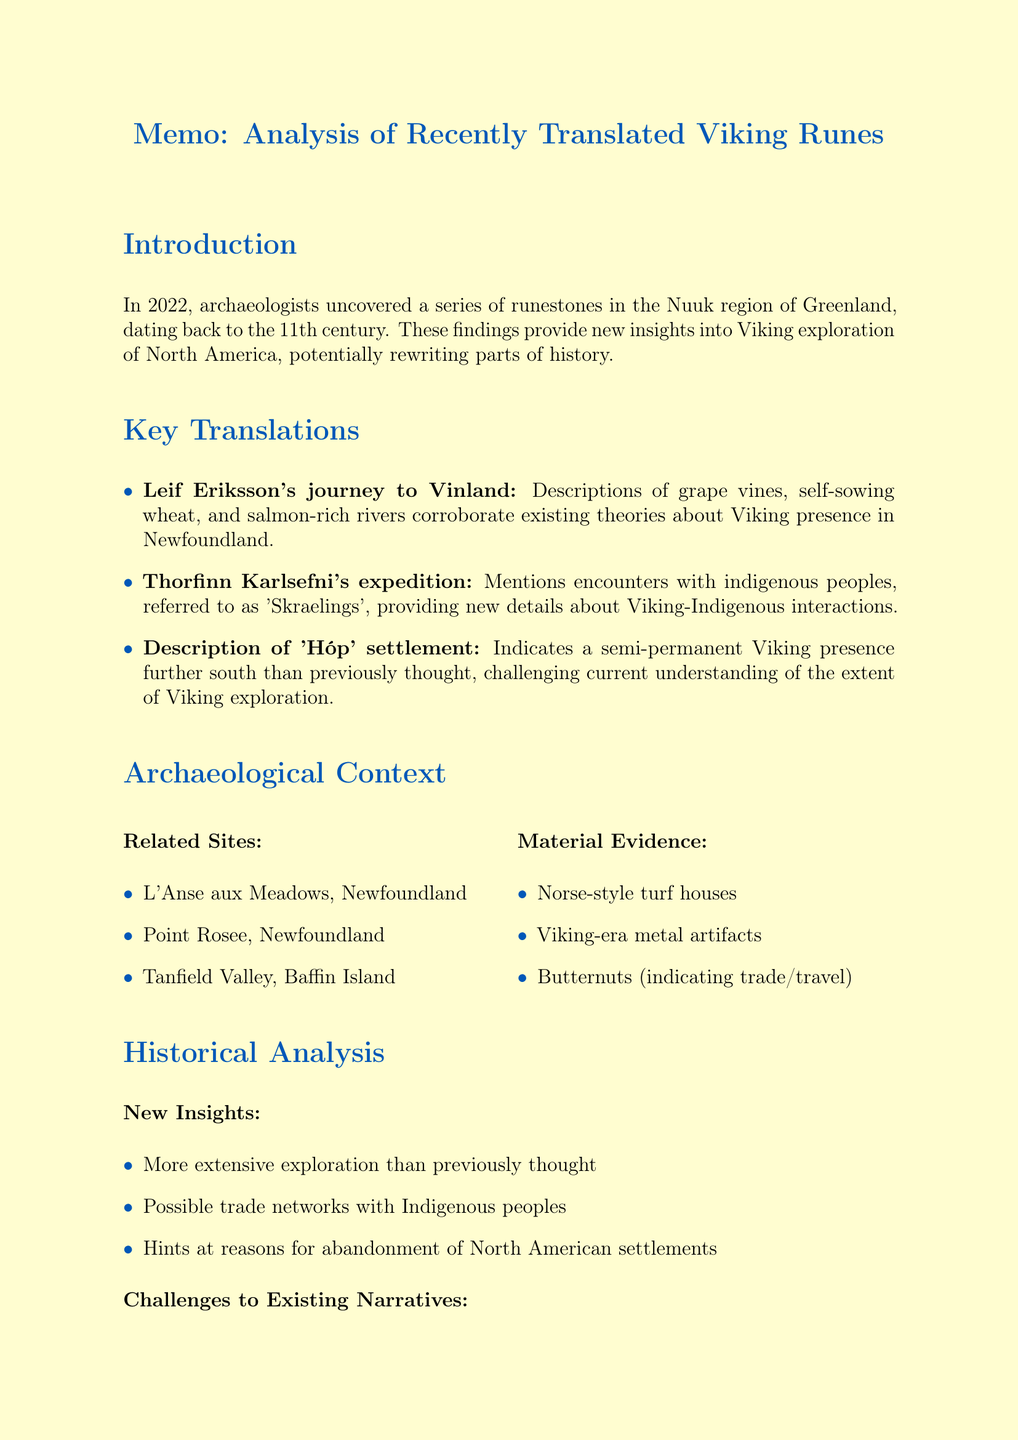What year were the runestones uncovered? The memo states that the runestones were uncovered in 2022.
Answer: 2022 How many runestones were found? The document indicates that a total of seven runestones were found.
Answer: 7 Who was the primary translator of the runes? The memo mentions Dr. Astrid Thorvaldsson as the primary translator.
Answer: Dr. Astrid Thorvaldsson What new insight is suggested about Viking exploration? The document highlights that there was more extensive exploration than previously thought.
Answer: More extensive exploration What is one of the related archaeological sites mentioned? The memo lists L'Anse aux Meadows as one of the related sites.
Answer: L'Anse aux Meadows What term is used to refer to the Indigenous peoples encountered by the Vikings? The runes referred to Indigenous peoples as 'Skraelings'.
Answer: Skraelings What does the settlement 'Hóp' indicate? The document states that 'Hóp' indicates a semi-permanent Viking presence further south than previously thought.
Answer: Semi-permanent Viking presence What is recommended for future research? The document suggests the need for more extensive archaeological surveys in coastal regions of North America.
Answer: More extensive archaeological surveys 